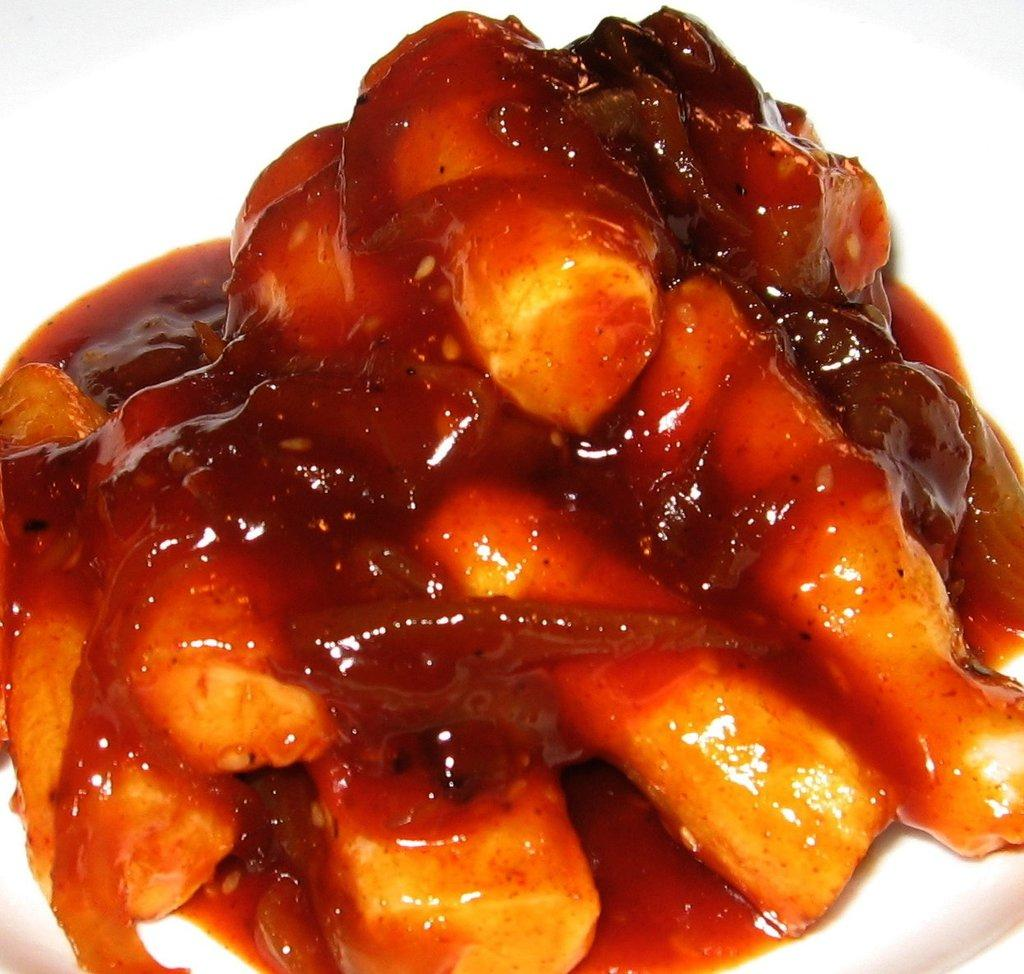What can be seen in the image? There are food items in the image. Where are the food items located? The food items are on a platform. What type of dress is the farmer wearing in the image? There is no farmer or dress present in the image. How many tickets can be seen in the image? There are no tickets present in the image. 